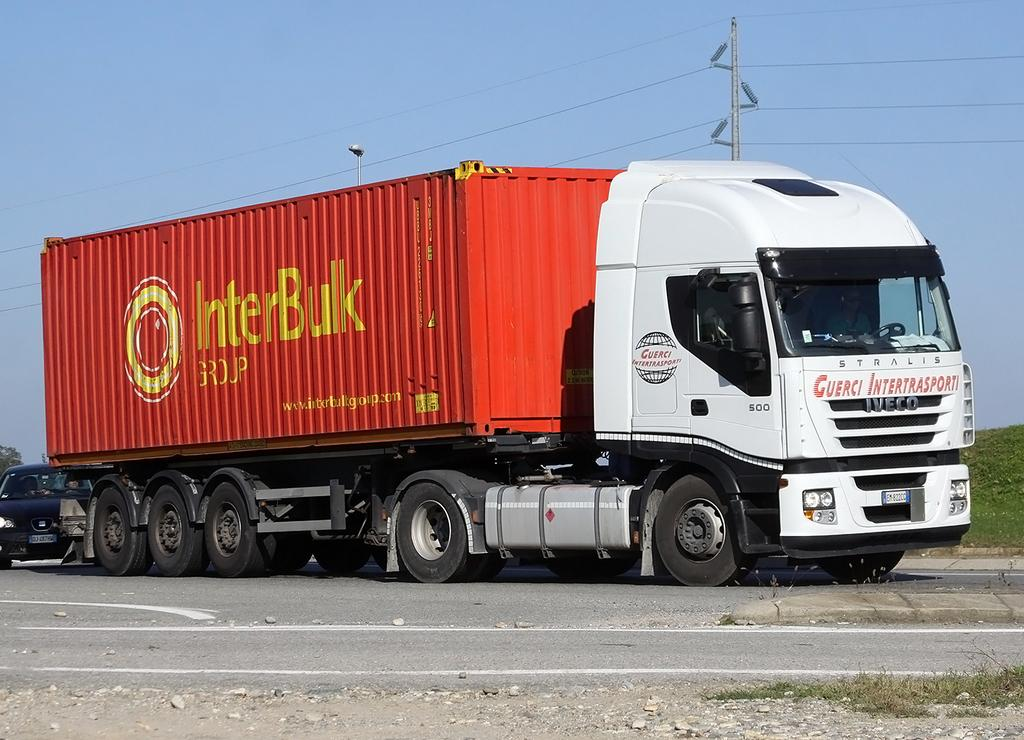What types of objects are present in the image? There are vehicles, stones, poles, and wires in the image. What can be seen on the ground in the image? The ground is visible in the image, and there is grass on it. What is visible in the sky in the image? The sky is visible in the image. What type of sweater is the person wearing in the image? There is no person wearing a sweater in the image; it features vehicles, stones, poles, and wires. How does the laughter sound in the image? There is no laughter present in the image; it features vehicles, stones, poles, and wires. 